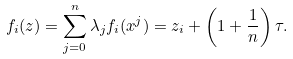Convert formula to latex. <formula><loc_0><loc_0><loc_500><loc_500>f _ { i } ( z ) = \sum _ { j = 0 } ^ { n } \lambda _ { j } f _ { i } ( x ^ { j } ) = z _ { i } + \left ( 1 + \frac { 1 } { n } \right ) \tau .</formula> 